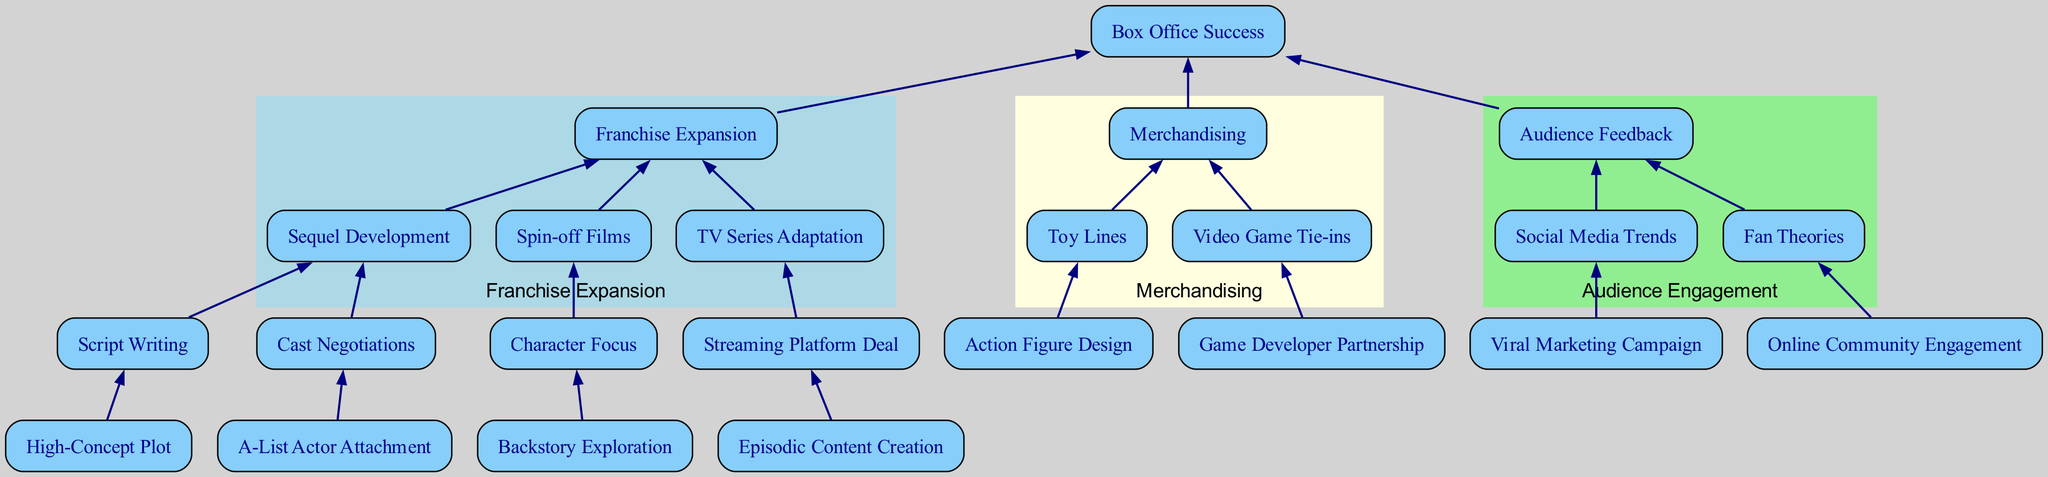What is the top node of the diagram? The top node "Box Office Success" represents the overall goal for the movie franchise development pipeline. It is the starting point for understanding everything that follows it.
Answer: Box Office Success How many child nodes does "Franchise Expansion" have? "Franchise Expansion" directly leads to three child nodes: "Sequel Development", "Spin-off Films", and "TV Series Adaptation". Therefore, it has three children.
Answer: 3 What is the last step in the "Merchandising" branch? The last step in the "Merchandising" branch is "Video Game Tie-ins", which is a child of "Merchandising". It finalizes the exploration of merchandise options associated with the franchise.
Answer: Video Game Tie-ins What are the two main outcomes of "Audience Feedback"? "Audience Feedback" leads to two outcomes: "Social Media Trends" and "Fan Theories". These are the reactions from the audience that can influence future development decisions based on their engagement and theories.
Answer: Social Media Trends, Fan Theories What do "Sequel Development" and "Spin-off Films" have in common? Both "Sequel Development" and "Spin-off Films" are children of "Franchise Expansion", indicating they are both methods of expanding the franchise after its initial success. They represent different strategies to leverage the franchise’s popularity.
Answer: Franchise Expansion How does "Box Office Success" influence the pipeline? "Box Office Success" is the initial driving force in the diagram. It dictates whether further developments like sequels, merchandising, or audience engagement strategies will take place. If the box office is successful, it prompts more expansion in various avenues.
Answer: Franchise Expansion What is the relationship between "Cast Negotiations" and "Script Writing"? "Cast Negotiations" is a subsequent step following "Script Writing" as part of the "Sequel Development" process. It relies on the successful completion of the script to negotiate with actors for roles.
Answer: Sequel Development Which node leads to the "Streaming Platform Deal"? "TV Series Adaptation" leads to the "Streaming Platform Deal". This indicates that adapting a franchise into a TV series often necessitates a deal with streaming platforms for distribution and viewership.
Answer: Streaming Platform Deal What does "High-Concept Plot" signify in the pipeline? "High-Concept Plot" in the context of "Script Writing" means creating a storyline that is appealing and commercially viable, crucial for the development of sequels and ensuring the franchise’s success.
Answer: Script Writing 